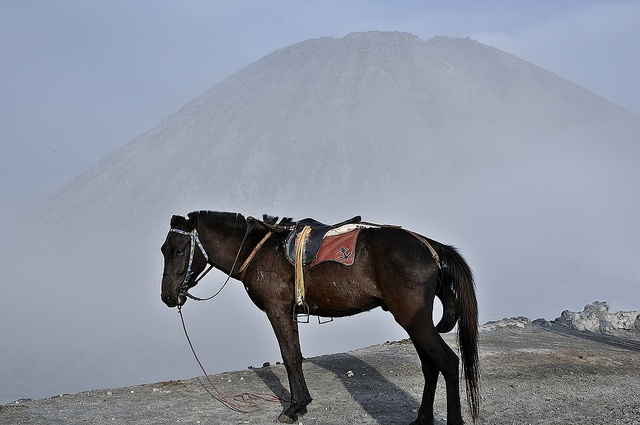Describe the objects in this image and their specific colors. I can see a horse in darkgray, black, and gray tones in this image. 